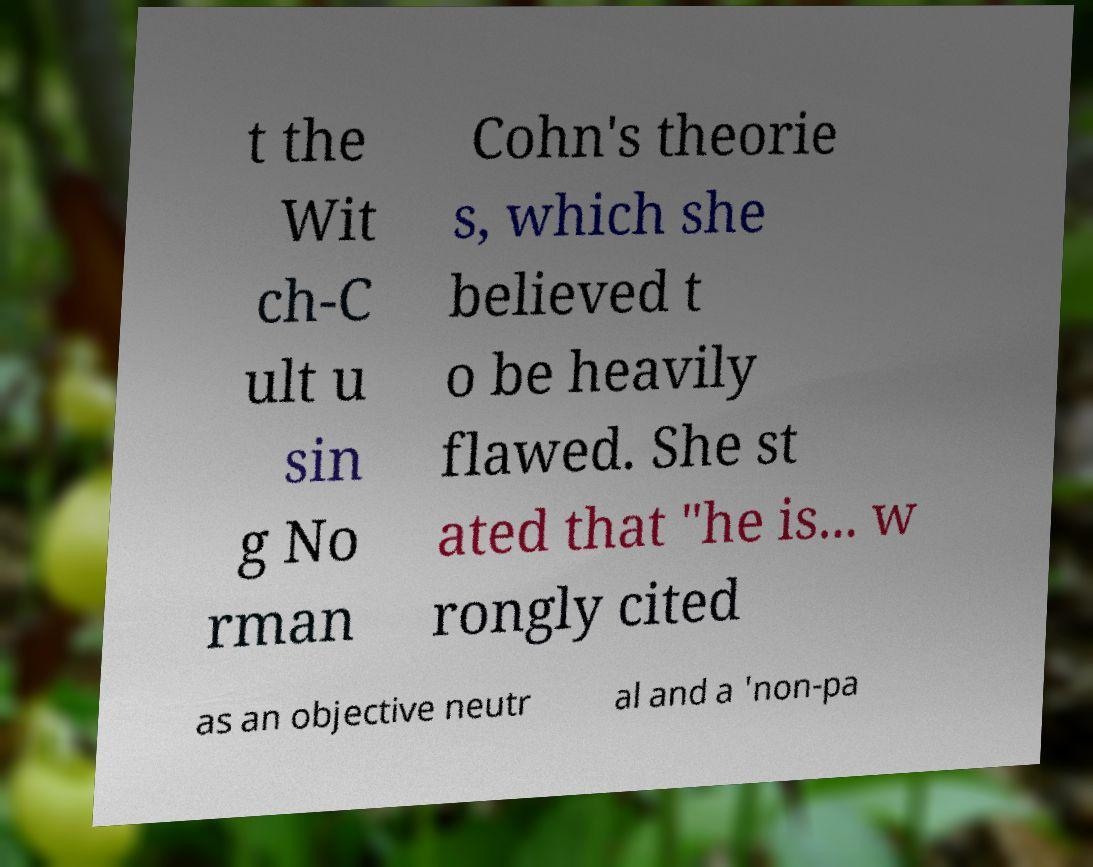What messages or text are displayed in this image? I need them in a readable, typed format. t the Wit ch-C ult u sin g No rman Cohn's theorie s, which she believed t o be heavily flawed. She st ated that "he is... w rongly cited as an objective neutr al and a 'non-pa 